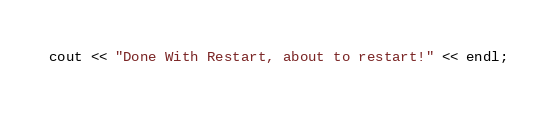Convert code to text. <code><loc_0><loc_0><loc_500><loc_500><_ObjectiveC_>cout << "Done With Restart, about to restart!" << endl;
</code> 